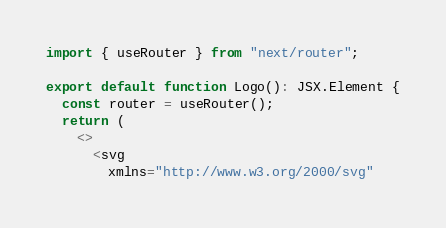<code> <loc_0><loc_0><loc_500><loc_500><_TypeScript_>import { useRouter } from "next/router";

export default function Logo(): JSX.Element {
  const router = useRouter();
  return (
    <>
      <svg
        xmlns="http://www.w3.org/2000/svg"</code> 